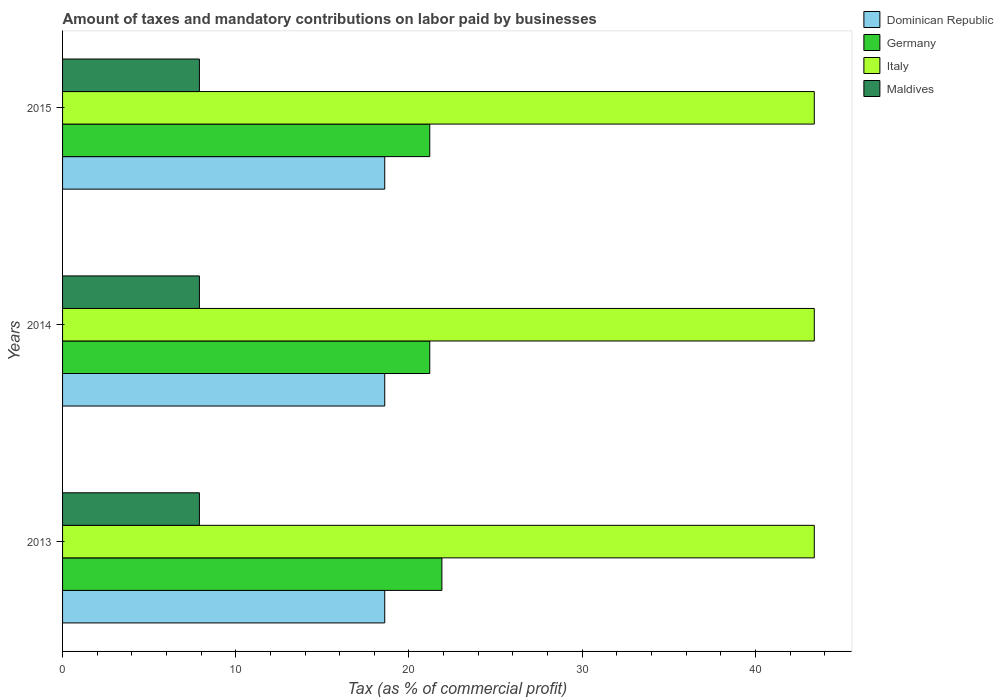How many groups of bars are there?
Give a very brief answer. 3. How many bars are there on the 2nd tick from the top?
Your response must be concise. 4. How many bars are there on the 3rd tick from the bottom?
Offer a terse response. 4. What is the label of the 3rd group of bars from the top?
Your response must be concise. 2013. In how many cases, is the number of bars for a given year not equal to the number of legend labels?
Your answer should be compact. 0. What is the percentage of taxes paid by businesses in Dominican Republic in 2015?
Offer a terse response. 18.6. Across all years, what is the minimum percentage of taxes paid by businesses in Germany?
Your answer should be very brief. 21.2. In which year was the percentage of taxes paid by businesses in Germany maximum?
Your answer should be very brief. 2013. What is the total percentage of taxes paid by businesses in Italy in the graph?
Keep it short and to the point. 130.2. What is the difference between the percentage of taxes paid by businesses in Maldives in 2014 and the percentage of taxes paid by businesses in Germany in 2013?
Your answer should be very brief. -14. What is the average percentage of taxes paid by businesses in Italy per year?
Keep it short and to the point. 43.4. In the year 2013, what is the difference between the percentage of taxes paid by businesses in Dominican Republic and percentage of taxes paid by businesses in Maldives?
Give a very brief answer. 10.7. What is the ratio of the percentage of taxes paid by businesses in Italy in 2013 to that in 2014?
Your response must be concise. 1. Is the percentage of taxes paid by businesses in Dominican Republic in 2013 less than that in 2014?
Your response must be concise. No. What is the difference between the highest and the second highest percentage of taxes paid by businesses in Dominican Republic?
Your answer should be compact. 0. What is the difference between the highest and the lowest percentage of taxes paid by businesses in Dominican Republic?
Your answer should be compact. 0. Is the sum of the percentage of taxes paid by businesses in Italy in 2013 and 2015 greater than the maximum percentage of taxes paid by businesses in Dominican Republic across all years?
Your response must be concise. Yes. Is it the case that in every year, the sum of the percentage of taxes paid by businesses in Maldives and percentage of taxes paid by businesses in Germany is greater than the sum of percentage of taxes paid by businesses in Italy and percentage of taxes paid by businesses in Dominican Republic?
Your answer should be compact. Yes. What does the 3rd bar from the top in 2013 represents?
Your answer should be very brief. Germany. What does the 4th bar from the bottom in 2014 represents?
Provide a succinct answer. Maldives. Is it the case that in every year, the sum of the percentage of taxes paid by businesses in Italy and percentage of taxes paid by businesses in Maldives is greater than the percentage of taxes paid by businesses in Germany?
Provide a succinct answer. Yes. How many bars are there?
Make the answer very short. 12. Are all the bars in the graph horizontal?
Make the answer very short. Yes. Where does the legend appear in the graph?
Provide a succinct answer. Top right. How are the legend labels stacked?
Make the answer very short. Vertical. What is the title of the graph?
Provide a short and direct response. Amount of taxes and mandatory contributions on labor paid by businesses. What is the label or title of the X-axis?
Give a very brief answer. Tax (as % of commercial profit). What is the label or title of the Y-axis?
Your answer should be compact. Years. What is the Tax (as % of commercial profit) of Dominican Republic in 2013?
Make the answer very short. 18.6. What is the Tax (as % of commercial profit) in Germany in 2013?
Keep it short and to the point. 21.9. What is the Tax (as % of commercial profit) of Italy in 2013?
Offer a terse response. 43.4. What is the Tax (as % of commercial profit) of Maldives in 2013?
Offer a very short reply. 7.9. What is the Tax (as % of commercial profit) of Germany in 2014?
Give a very brief answer. 21.2. What is the Tax (as % of commercial profit) in Italy in 2014?
Offer a very short reply. 43.4. What is the Tax (as % of commercial profit) in Dominican Republic in 2015?
Your answer should be very brief. 18.6. What is the Tax (as % of commercial profit) in Germany in 2015?
Offer a very short reply. 21.2. What is the Tax (as % of commercial profit) of Italy in 2015?
Offer a very short reply. 43.4. Across all years, what is the maximum Tax (as % of commercial profit) in Dominican Republic?
Offer a very short reply. 18.6. Across all years, what is the maximum Tax (as % of commercial profit) in Germany?
Provide a short and direct response. 21.9. Across all years, what is the maximum Tax (as % of commercial profit) in Italy?
Your answer should be very brief. 43.4. Across all years, what is the minimum Tax (as % of commercial profit) in Dominican Republic?
Give a very brief answer. 18.6. Across all years, what is the minimum Tax (as % of commercial profit) of Germany?
Provide a short and direct response. 21.2. Across all years, what is the minimum Tax (as % of commercial profit) in Italy?
Your answer should be compact. 43.4. What is the total Tax (as % of commercial profit) in Dominican Republic in the graph?
Your answer should be very brief. 55.8. What is the total Tax (as % of commercial profit) in Germany in the graph?
Your answer should be very brief. 64.3. What is the total Tax (as % of commercial profit) of Italy in the graph?
Offer a terse response. 130.2. What is the total Tax (as % of commercial profit) in Maldives in the graph?
Make the answer very short. 23.7. What is the difference between the Tax (as % of commercial profit) in Dominican Republic in 2013 and that in 2014?
Your response must be concise. 0. What is the difference between the Tax (as % of commercial profit) of Germany in 2013 and that in 2014?
Provide a succinct answer. 0.7. What is the difference between the Tax (as % of commercial profit) in Italy in 2013 and that in 2014?
Offer a very short reply. 0. What is the difference between the Tax (as % of commercial profit) in Maldives in 2013 and that in 2014?
Give a very brief answer. 0. What is the difference between the Tax (as % of commercial profit) in Germany in 2013 and that in 2015?
Your answer should be very brief. 0.7. What is the difference between the Tax (as % of commercial profit) of Germany in 2014 and that in 2015?
Ensure brevity in your answer.  0. What is the difference between the Tax (as % of commercial profit) in Maldives in 2014 and that in 2015?
Give a very brief answer. 0. What is the difference between the Tax (as % of commercial profit) of Dominican Republic in 2013 and the Tax (as % of commercial profit) of Italy in 2014?
Offer a very short reply. -24.8. What is the difference between the Tax (as % of commercial profit) of Dominican Republic in 2013 and the Tax (as % of commercial profit) of Maldives in 2014?
Give a very brief answer. 10.7. What is the difference between the Tax (as % of commercial profit) in Germany in 2013 and the Tax (as % of commercial profit) in Italy in 2014?
Your answer should be very brief. -21.5. What is the difference between the Tax (as % of commercial profit) in Italy in 2013 and the Tax (as % of commercial profit) in Maldives in 2014?
Give a very brief answer. 35.5. What is the difference between the Tax (as % of commercial profit) of Dominican Republic in 2013 and the Tax (as % of commercial profit) of Germany in 2015?
Provide a succinct answer. -2.6. What is the difference between the Tax (as % of commercial profit) of Dominican Republic in 2013 and the Tax (as % of commercial profit) of Italy in 2015?
Your answer should be very brief. -24.8. What is the difference between the Tax (as % of commercial profit) of Germany in 2013 and the Tax (as % of commercial profit) of Italy in 2015?
Offer a very short reply. -21.5. What is the difference between the Tax (as % of commercial profit) of Italy in 2013 and the Tax (as % of commercial profit) of Maldives in 2015?
Make the answer very short. 35.5. What is the difference between the Tax (as % of commercial profit) in Dominican Republic in 2014 and the Tax (as % of commercial profit) in Italy in 2015?
Ensure brevity in your answer.  -24.8. What is the difference between the Tax (as % of commercial profit) of Germany in 2014 and the Tax (as % of commercial profit) of Italy in 2015?
Make the answer very short. -22.2. What is the difference between the Tax (as % of commercial profit) in Germany in 2014 and the Tax (as % of commercial profit) in Maldives in 2015?
Your answer should be very brief. 13.3. What is the difference between the Tax (as % of commercial profit) in Italy in 2014 and the Tax (as % of commercial profit) in Maldives in 2015?
Provide a succinct answer. 35.5. What is the average Tax (as % of commercial profit) of Dominican Republic per year?
Your answer should be compact. 18.6. What is the average Tax (as % of commercial profit) of Germany per year?
Your answer should be very brief. 21.43. What is the average Tax (as % of commercial profit) of Italy per year?
Provide a short and direct response. 43.4. In the year 2013, what is the difference between the Tax (as % of commercial profit) in Dominican Republic and Tax (as % of commercial profit) in Italy?
Your response must be concise. -24.8. In the year 2013, what is the difference between the Tax (as % of commercial profit) of Germany and Tax (as % of commercial profit) of Italy?
Your answer should be very brief. -21.5. In the year 2013, what is the difference between the Tax (as % of commercial profit) in Italy and Tax (as % of commercial profit) in Maldives?
Make the answer very short. 35.5. In the year 2014, what is the difference between the Tax (as % of commercial profit) of Dominican Republic and Tax (as % of commercial profit) of Germany?
Offer a terse response. -2.6. In the year 2014, what is the difference between the Tax (as % of commercial profit) of Dominican Republic and Tax (as % of commercial profit) of Italy?
Your answer should be very brief. -24.8. In the year 2014, what is the difference between the Tax (as % of commercial profit) in Dominican Republic and Tax (as % of commercial profit) in Maldives?
Make the answer very short. 10.7. In the year 2014, what is the difference between the Tax (as % of commercial profit) of Germany and Tax (as % of commercial profit) of Italy?
Keep it short and to the point. -22.2. In the year 2014, what is the difference between the Tax (as % of commercial profit) in Italy and Tax (as % of commercial profit) in Maldives?
Your response must be concise. 35.5. In the year 2015, what is the difference between the Tax (as % of commercial profit) of Dominican Republic and Tax (as % of commercial profit) of Italy?
Keep it short and to the point. -24.8. In the year 2015, what is the difference between the Tax (as % of commercial profit) of Dominican Republic and Tax (as % of commercial profit) of Maldives?
Your answer should be compact. 10.7. In the year 2015, what is the difference between the Tax (as % of commercial profit) of Germany and Tax (as % of commercial profit) of Italy?
Ensure brevity in your answer.  -22.2. In the year 2015, what is the difference between the Tax (as % of commercial profit) of Italy and Tax (as % of commercial profit) of Maldives?
Make the answer very short. 35.5. What is the ratio of the Tax (as % of commercial profit) in Dominican Republic in 2013 to that in 2014?
Make the answer very short. 1. What is the ratio of the Tax (as % of commercial profit) in Germany in 2013 to that in 2014?
Your answer should be very brief. 1.03. What is the ratio of the Tax (as % of commercial profit) in Dominican Republic in 2013 to that in 2015?
Keep it short and to the point. 1. What is the ratio of the Tax (as % of commercial profit) of Germany in 2013 to that in 2015?
Your answer should be very brief. 1.03. What is the ratio of the Tax (as % of commercial profit) of Dominican Republic in 2014 to that in 2015?
Offer a very short reply. 1. What is the difference between the highest and the second highest Tax (as % of commercial profit) in Germany?
Provide a short and direct response. 0.7. What is the difference between the highest and the lowest Tax (as % of commercial profit) in Maldives?
Make the answer very short. 0. 